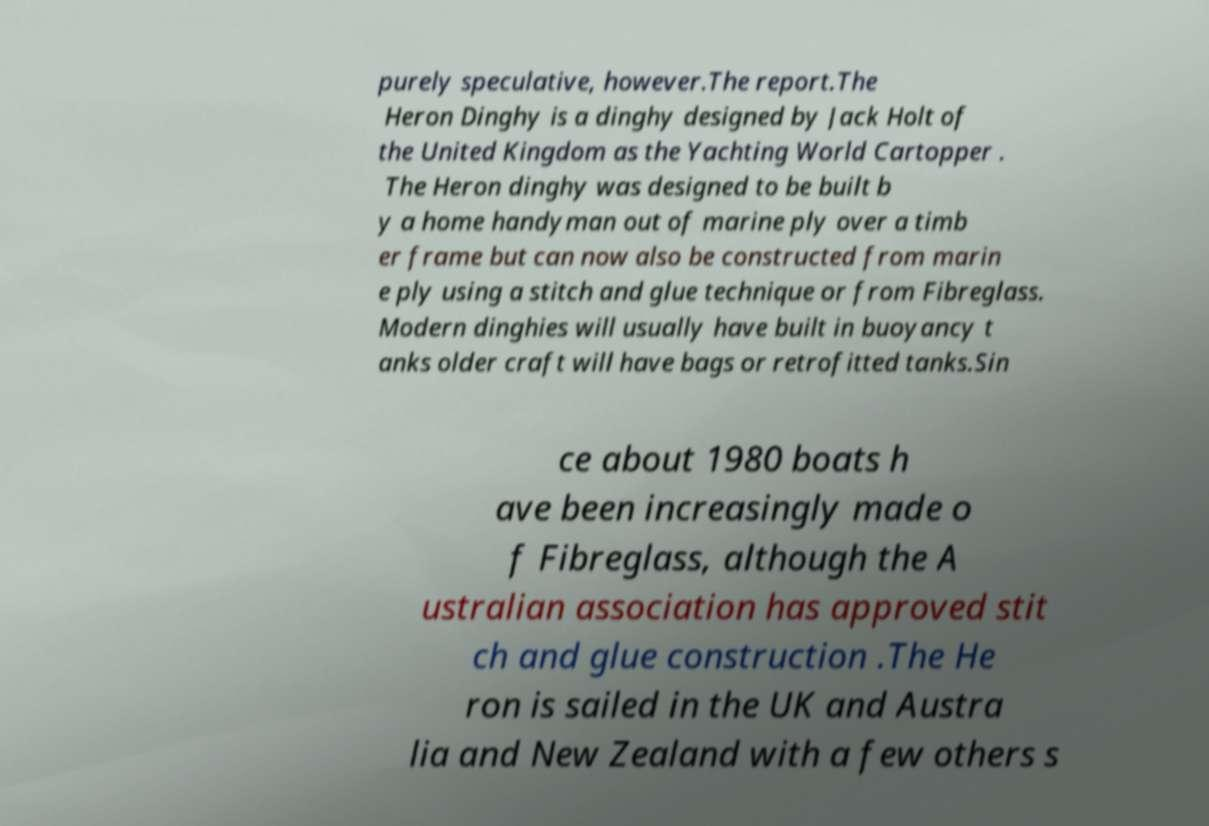Could you assist in decoding the text presented in this image and type it out clearly? purely speculative, however.The report.The Heron Dinghy is a dinghy designed by Jack Holt of the United Kingdom as the Yachting World Cartopper . The Heron dinghy was designed to be built b y a home handyman out of marine ply over a timb er frame but can now also be constructed from marin e ply using a stitch and glue technique or from Fibreglass. Modern dinghies will usually have built in buoyancy t anks older craft will have bags or retrofitted tanks.Sin ce about 1980 boats h ave been increasingly made o f Fibreglass, although the A ustralian association has approved stit ch and glue construction .The He ron is sailed in the UK and Austra lia and New Zealand with a few others s 